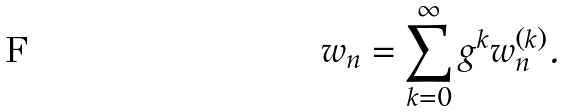Convert formula to latex. <formula><loc_0><loc_0><loc_500><loc_500>w _ { n } = \sum _ { k = 0 } ^ { \infty } g ^ { k } w _ { n } ^ { ( k ) } .</formula> 